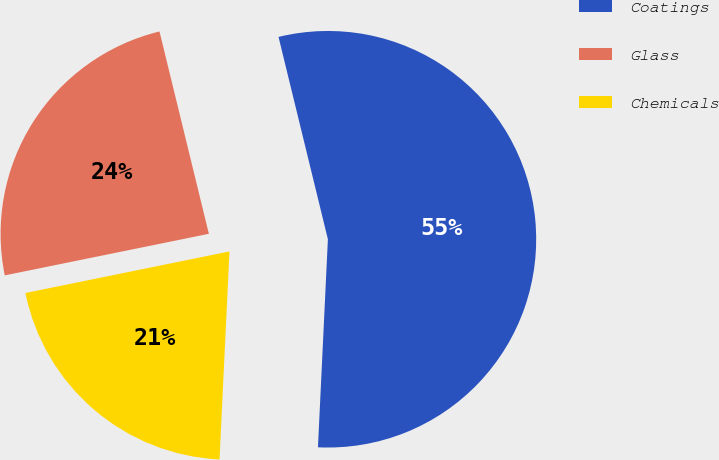Convert chart to OTSL. <chart><loc_0><loc_0><loc_500><loc_500><pie_chart><fcel>Coatings<fcel>Glass<fcel>Chemicals<nl><fcel>54.57%<fcel>24.39%<fcel>21.04%<nl></chart> 